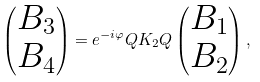<formula> <loc_0><loc_0><loc_500><loc_500>\begin{pmatrix} B _ { 3 } \\ B _ { 4 } \\ \end{pmatrix} = e ^ { - i \varphi } Q K _ { 2 } Q \begin{pmatrix} B _ { 1 } \\ B _ { 2 } \\ \end{pmatrix} ,</formula> 